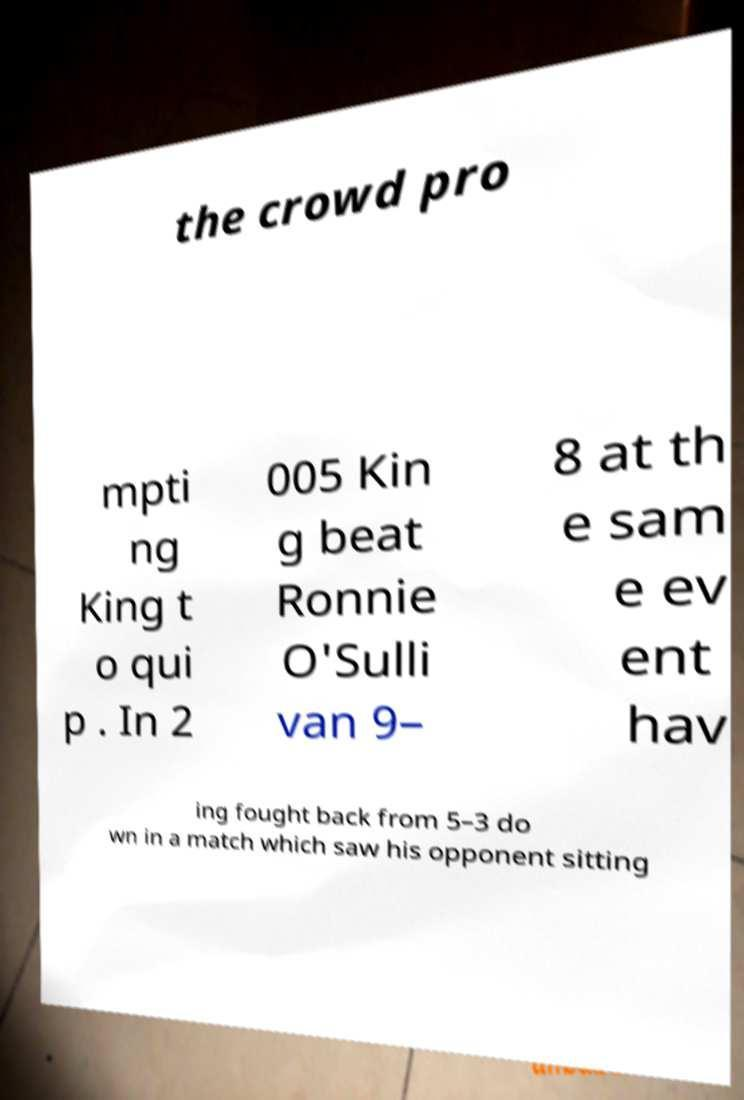What messages or text are displayed in this image? I need them in a readable, typed format. the crowd pro mpti ng King t o qui p . In 2 005 Kin g beat Ronnie O'Sulli van 9– 8 at th e sam e ev ent hav ing fought back from 5–3 do wn in a match which saw his opponent sitting 